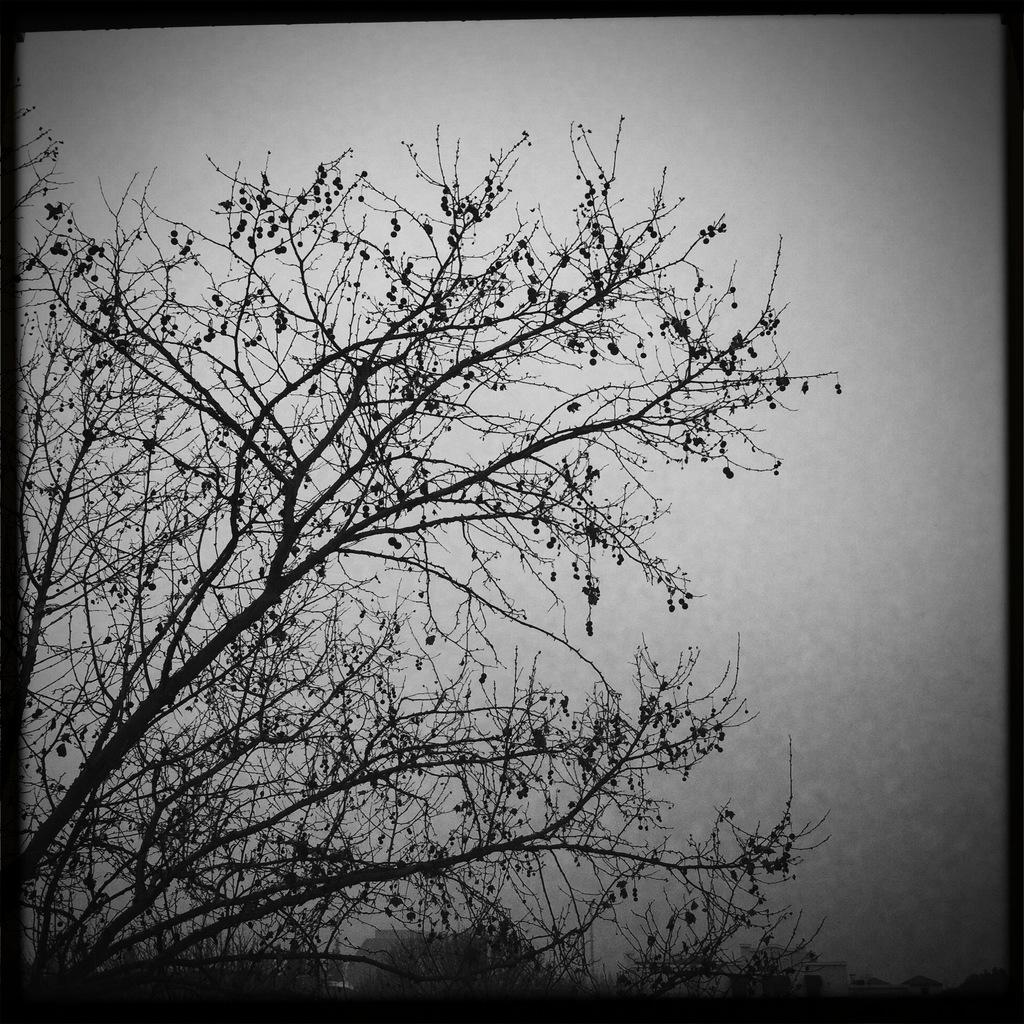What is the main object in the picture? There is a tree in the picture. What part of the tree is visible in the picture? Tree branches are visible in the picture. What can be seen in the background of the image? The background of the image is plain. Can you tell me how many times the wrench is used to touch the tree in the image? There is no wrench present in the image, and therefore no such interaction can be observed. 